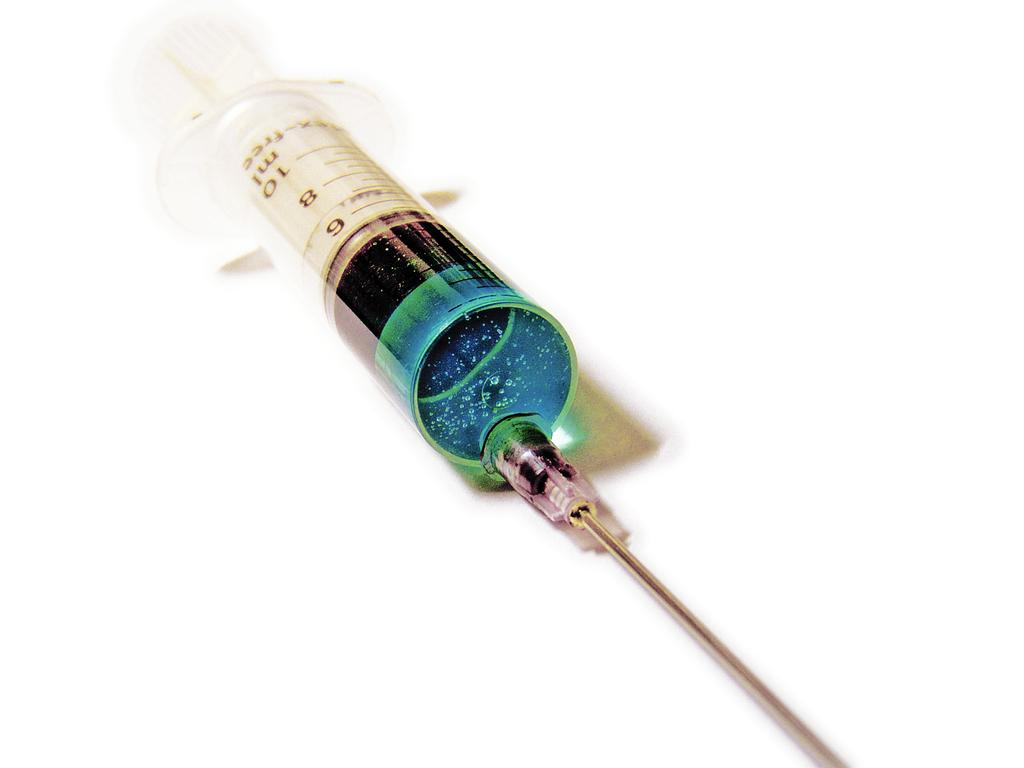What is the main object in the image? There is an injection with liquid in the image. What is attached to the injection? The injection has a needle. What color is the platform the injection is on? The platform the injection is on is white in color. How many cannons are visible in the image? There are no cannons present in the image. What type of pancake is being prepared on the platform? There is no pancake or preparation of food visible in the image. 